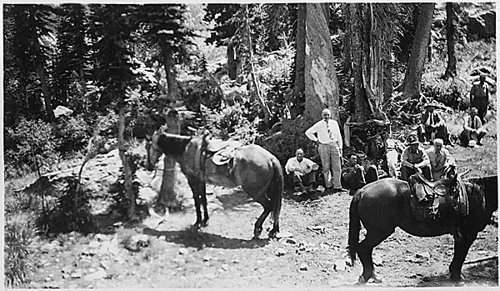Describe the objects in this image and their specific colors. I can see horse in lightgray, black, gray, and darkgray tones, horse in lightgray, black, gray, and darkgray tones, people in lightgray, gray, darkgray, and black tones, people in lightgray, black, gray, and darkgray tones, and people in lightgray, black, gray, and darkgray tones in this image. 